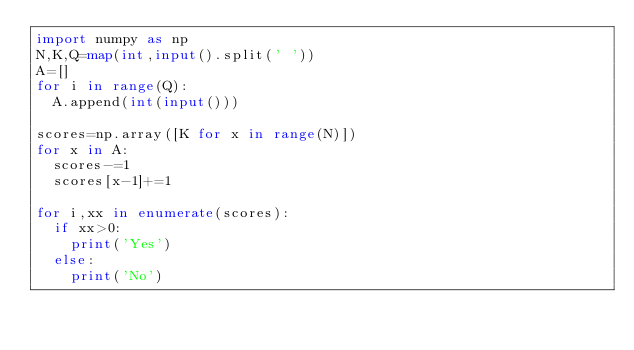Convert code to text. <code><loc_0><loc_0><loc_500><loc_500><_Python_>import numpy as np
N,K,Q=map(int,input().split(' '))
A=[]
for i in range(Q):
  A.append(int(input()))
  
scores=np.array([K for x in range(N)])
for x in A:
  scores-=1
  scores[x-1]+=1

for i,xx in enumerate(scores):
  if xx>0:
    print('Yes')
  else:
    print('No')
</code> 